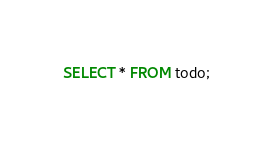<code> <loc_0><loc_0><loc_500><loc_500><_SQL_>SELECT * FROM todo;
</code> 